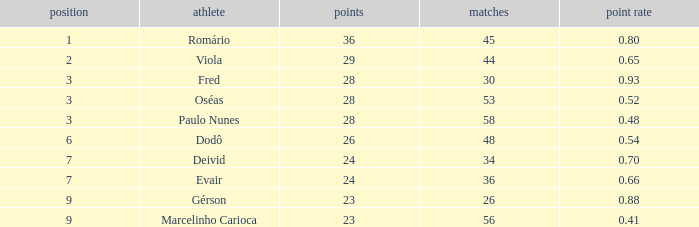What is the largest value for goals in rank over 3 with goal ration of 0.54? 26.0. Can you give me this table as a dict? {'header': ['position', 'athlete', 'points', 'matches', 'point rate'], 'rows': [['1', 'Romário', '36', '45', '0.80'], ['2', 'Viola', '29', '44', '0.65'], ['3', 'Fred', '28', '30', '0.93'], ['3', 'Oséas', '28', '53', '0.52'], ['3', 'Paulo Nunes', '28', '58', '0.48'], ['6', 'Dodô', '26', '48', '0.54'], ['7', 'Deivid', '24', '34', '0.70'], ['7', 'Evair', '24', '36', '0.66'], ['9', 'Gérson', '23', '26', '0.88'], ['9', 'Marcelinho Carioca', '23', '56', '0.41']]} 